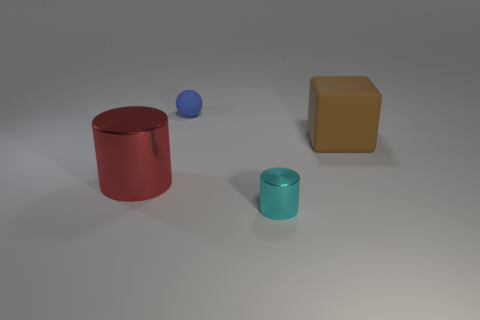Add 3 big brown matte blocks. How many objects exist? 7 Subtract all blocks. How many objects are left? 3 Subtract all yellow shiny objects. Subtract all cyan objects. How many objects are left? 3 Add 3 rubber things. How many rubber things are left? 5 Add 1 blue matte cylinders. How many blue matte cylinders exist? 1 Subtract 0 green cubes. How many objects are left? 4 